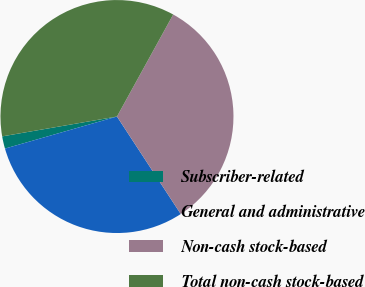Convert chart to OTSL. <chart><loc_0><loc_0><loc_500><loc_500><pie_chart><fcel>Subscriber-related<fcel>General and administrative<fcel>Non-cash stock-based<fcel>Total non-cash stock-based<nl><fcel>1.71%<fcel>29.78%<fcel>32.76%<fcel>35.74%<nl></chart> 